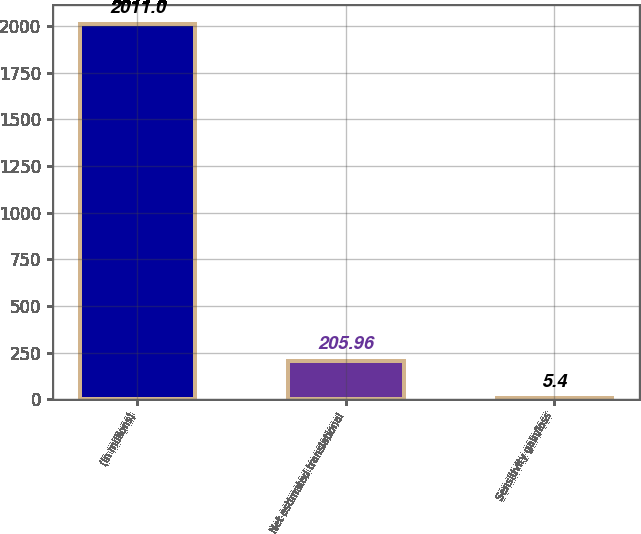<chart> <loc_0><loc_0><loc_500><loc_500><bar_chart><fcel>(in millions)<fcel>Net estimated translational<fcel>Sensitivity gain/loss<nl><fcel>2011<fcel>205.96<fcel>5.4<nl></chart> 